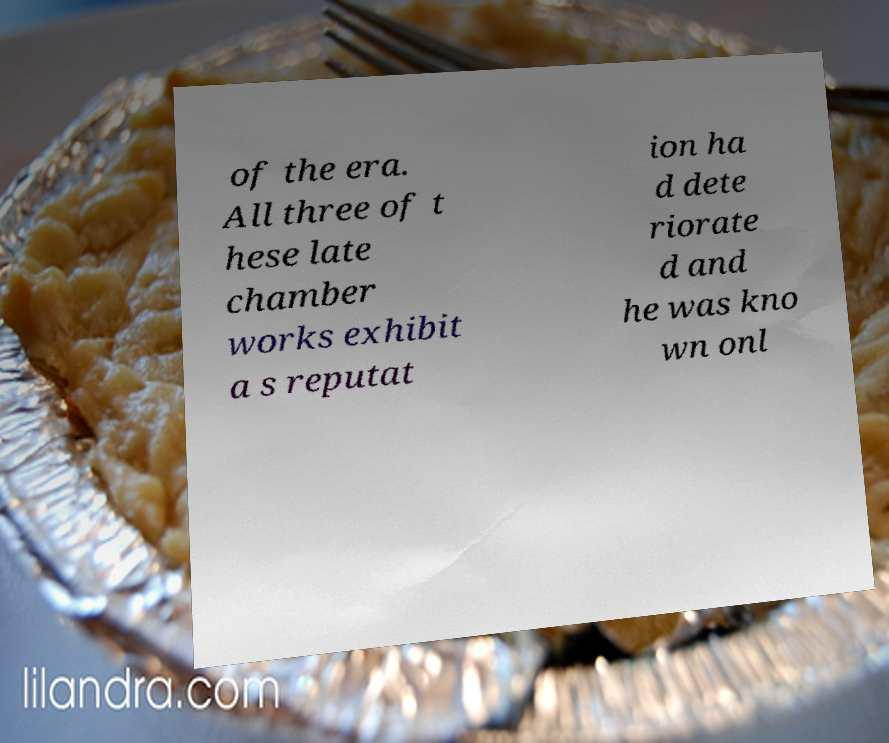There's text embedded in this image that I need extracted. Can you transcribe it verbatim? of the era. All three of t hese late chamber works exhibit a s reputat ion ha d dete riorate d and he was kno wn onl 